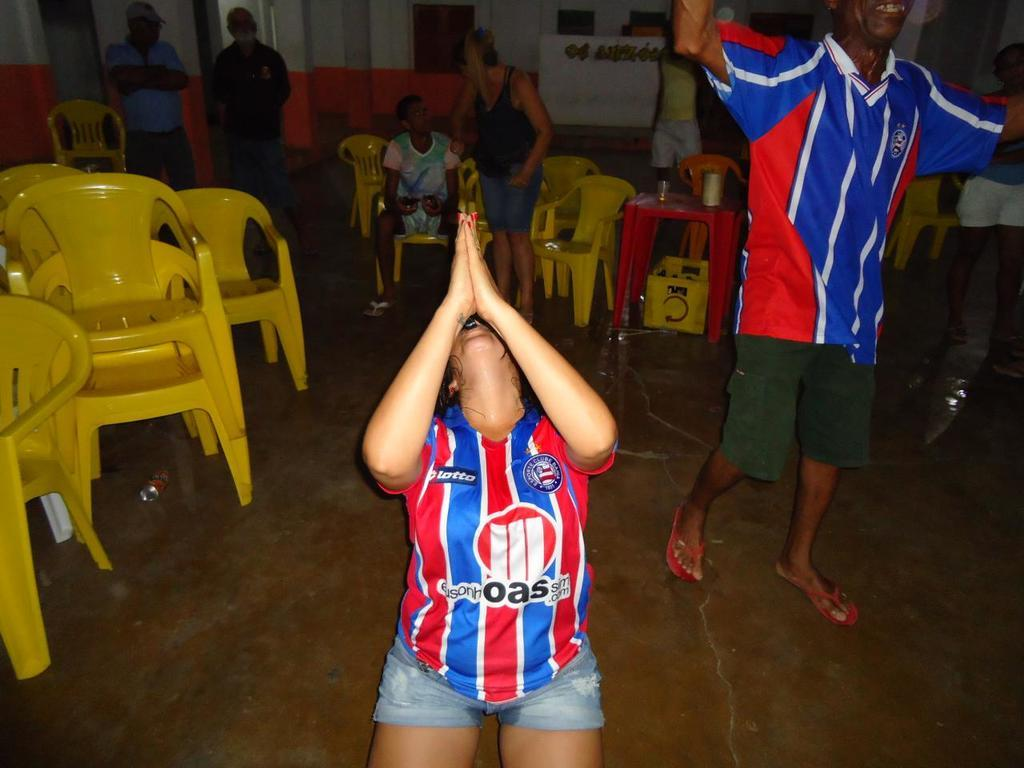What is the person in the image wearing? The person is wearing a football shirt. What is the person doing in the image? The person is waving their hand. What can be seen in the background of the image? There are chairs and people standing in the background of the image. What type of shoe is the person wearing in the image? The provided facts do not mention any shoes, so we cannot determine the type of shoe the person is wearing. 